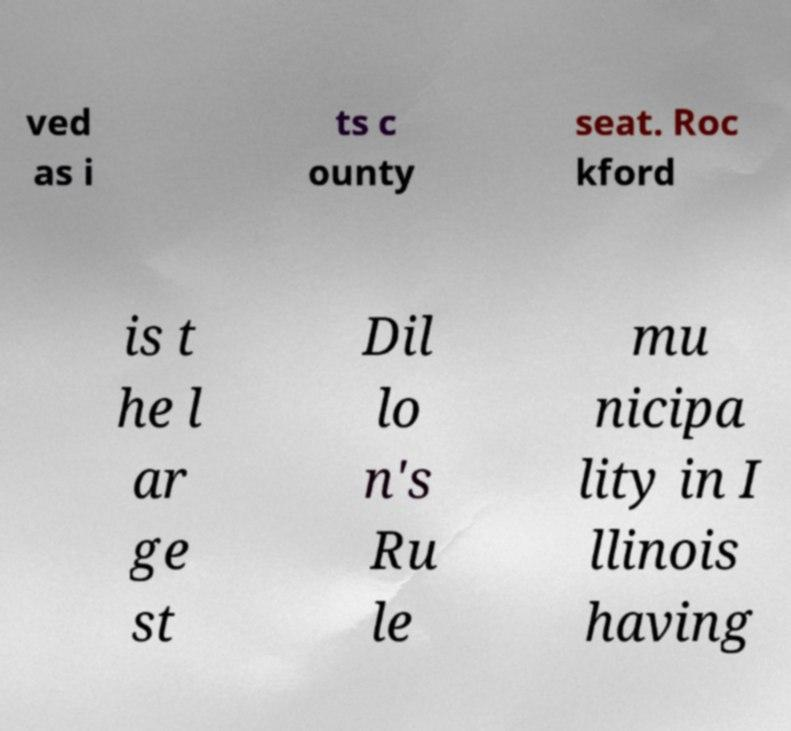What messages or text are displayed in this image? I need them in a readable, typed format. ved as i ts c ounty seat. Roc kford is t he l ar ge st Dil lo n's Ru le mu nicipa lity in I llinois having 